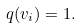<formula> <loc_0><loc_0><loc_500><loc_500>q ( v _ { i } ) = 1 .</formula> 